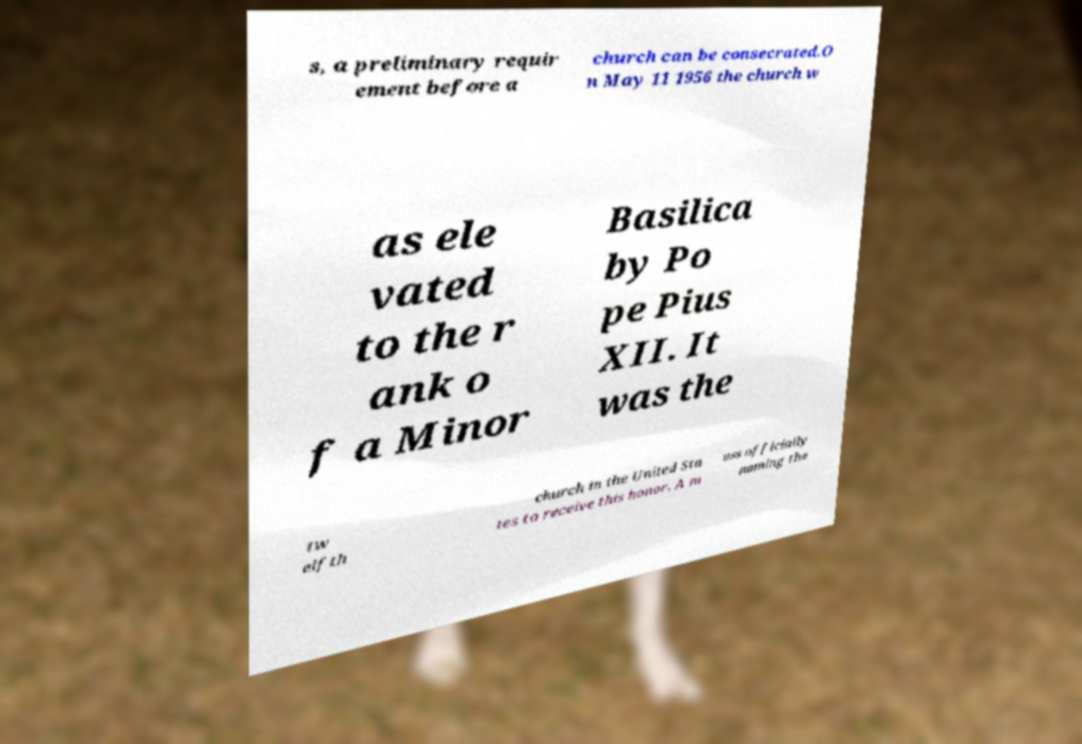Please identify and transcribe the text found in this image. s, a preliminary requir ement before a church can be consecrated.O n May 11 1956 the church w as ele vated to the r ank o f a Minor Basilica by Po pe Pius XII. It was the tw elfth church in the United Sta tes to receive this honor. A m ass officially naming the 